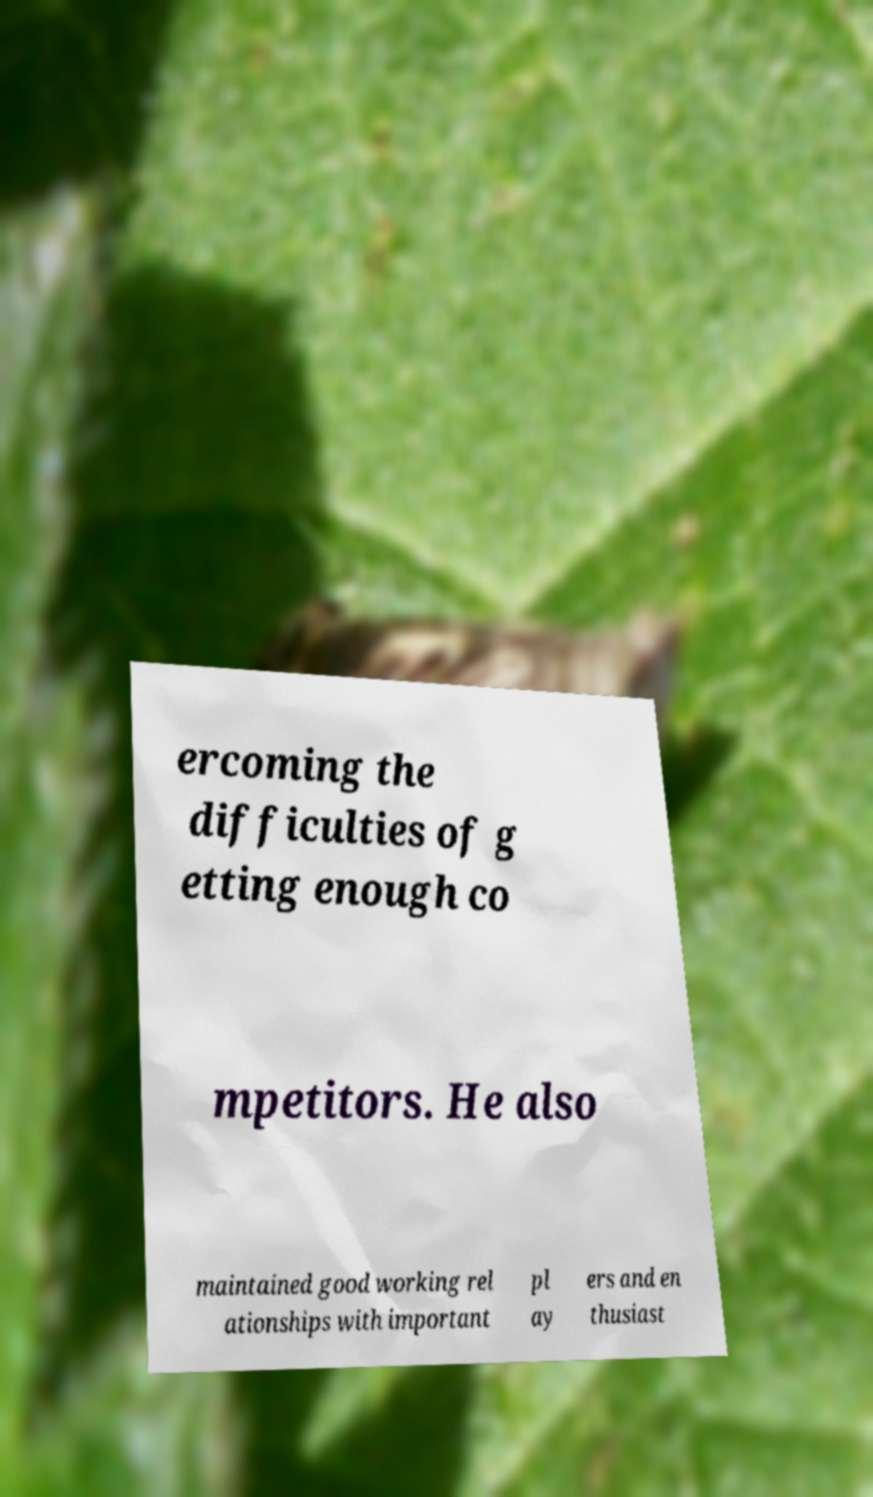There's text embedded in this image that I need extracted. Can you transcribe it verbatim? ercoming the difficulties of g etting enough co mpetitors. He also maintained good working rel ationships with important pl ay ers and en thusiast 